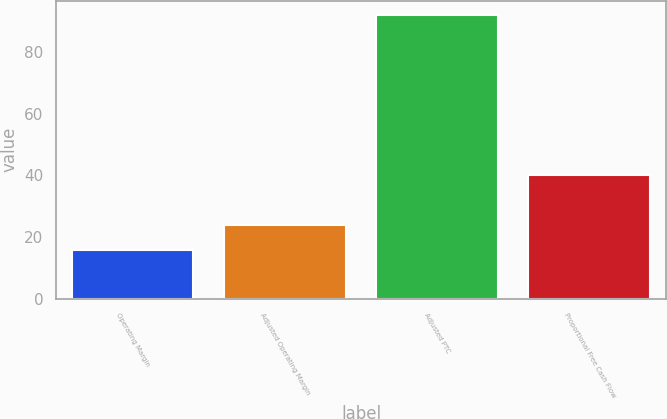Convert chart to OTSL. <chart><loc_0><loc_0><loc_500><loc_500><bar_chart><fcel>Operating Margin<fcel>Adjusted Operating Margin<fcel>Adjusted PTC<fcel>Proportional Free Cash Flow<nl><fcel>16<fcel>24<fcel>92<fcel>40<nl></chart> 